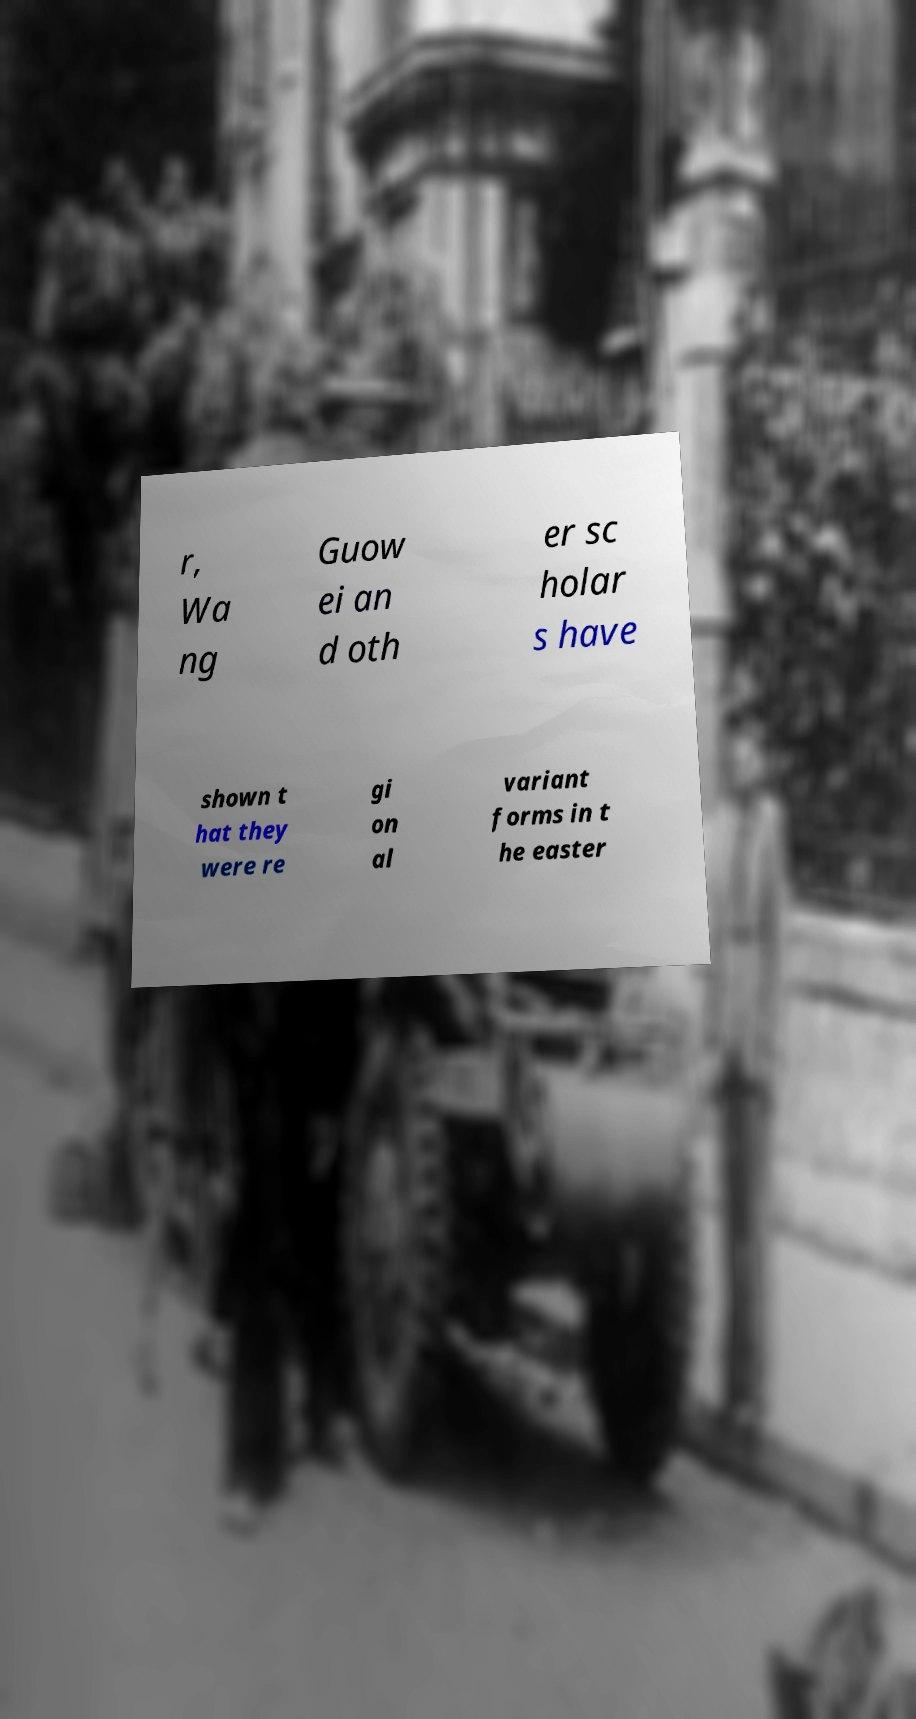Can you read and provide the text displayed in the image?This photo seems to have some interesting text. Can you extract and type it out for me? r, Wa ng Guow ei an d oth er sc holar s have shown t hat they were re gi on al variant forms in t he easter 